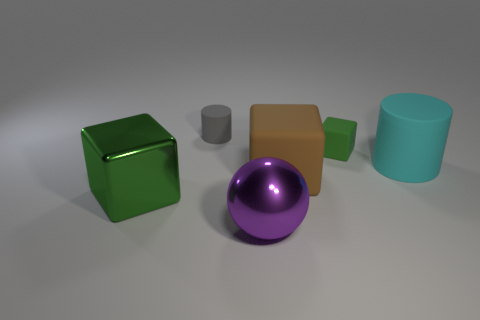There is a big thing on the left side of the small gray matte cylinder; is it the same color as the large cylinder?
Keep it short and to the point. No. What is the object that is behind the cyan rubber cylinder and in front of the small gray cylinder made of?
Provide a succinct answer. Rubber. How big is the cyan matte cylinder?
Provide a succinct answer. Large. There is a large metallic block; is it the same color as the cylinder in front of the small matte cylinder?
Make the answer very short. No. What number of other objects are the same color as the large metal block?
Ensure brevity in your answer.  1. Does the rubber thing on the left side of the metallic sphere have the same size as the rubber cylinder that is to the right of the large brown rubber cube?
Make the answer very short. No. What is the color of the rubber cylinder right of the big ball?
Your answer should be very brief. Cyan. Are there fewer big cyan objects behind the small cylinder than large metal blocks?
Provide a short and direct response. Yes. Is the material of the big green object the same as the large cyan cylinder?
Give a very brief answer. No. The other thing that is the same shape as the large cyan rubber object is what size?
Provide a short and direct response. Small. 